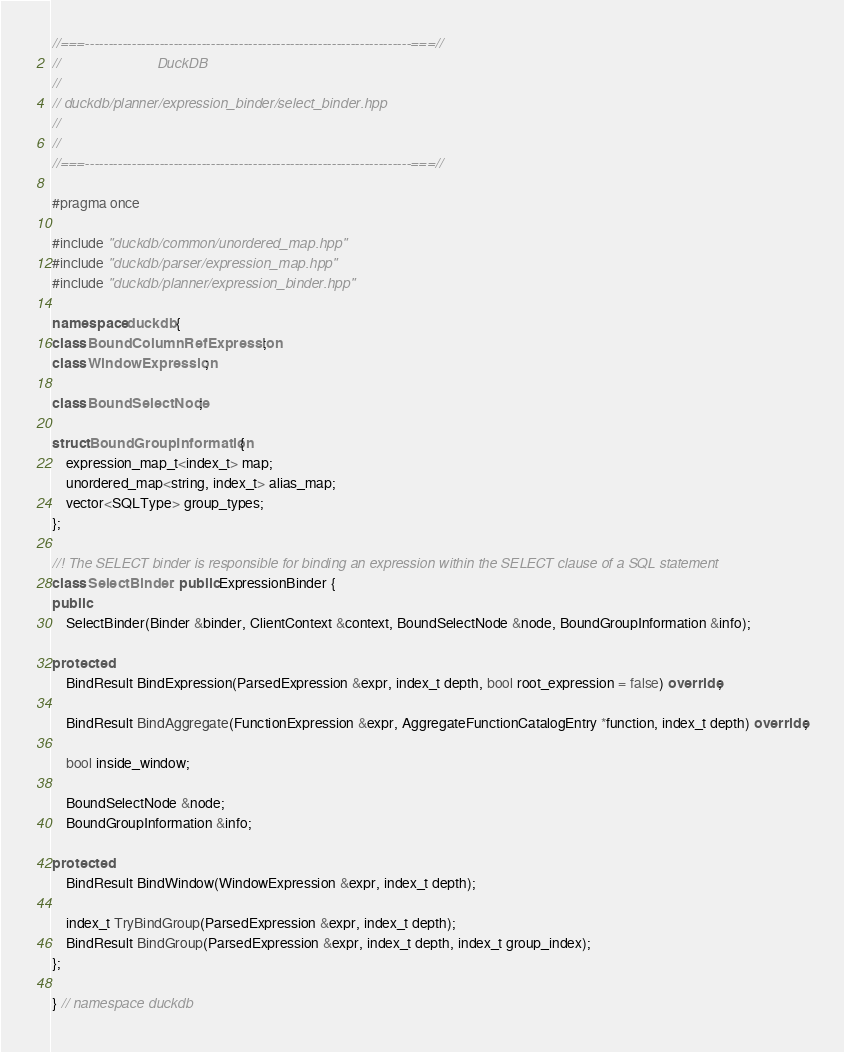<code> <loc_0><loc_0><loc_500><loc_500><_C++_>//===----------------------------------------------------------------------===//
//                         DuckDB
//
// duckdb/planner/expression_binder/select_binder.hpp
//
//
//===----------------------------------------------------------------------===//

#pragma once

#include "duckdb/common/unordered_map.hpp"
#include "duckdb/parser/expression_map.hpp"
#include "duckdb/planner/expression_binder.hpp"

namespace duckdb {
class BoundColumnRefExpression;
class WindowExpression;

class BoundSelectNode;

struct BoundGroupInformation {
	expression_map_t<index_t> map;
	unordered_map<string, index_t> alias_map;
	vector<SQLType> group_types;
};

//! The SELECT binder is responsible for binding an expression within the SELECT clause of a SQL statement
class SelectBinder : public ExpressionBinder {
public:
	SelectBinder(Binder &binder, ClientContext &context, BoundSelectNode &node, BoundGroupInformation &info);

protected:
	BindResult BindExpression(ParsedExpression &expr, index_t depth, bool root_expression = false) override;

	BindResult BindAggregate(FunctionExpression &expr, AggregateFunctionCatalogEntry *function, index_t depth) override;

	bool inside_window;

	BoundSelectNode &node;
	BoundGroupInformation &info;

protected:
	BindResult BindWindow(WindowExpression &expr, index_t depth);

	index_t TryBindGroup(ParsedExpression &expr, index_t depth);
	BindResult BindGroup(ParsedExpression &expr, index_t depth, index_t group_index);
};

} // namespace duckdb
</code> 